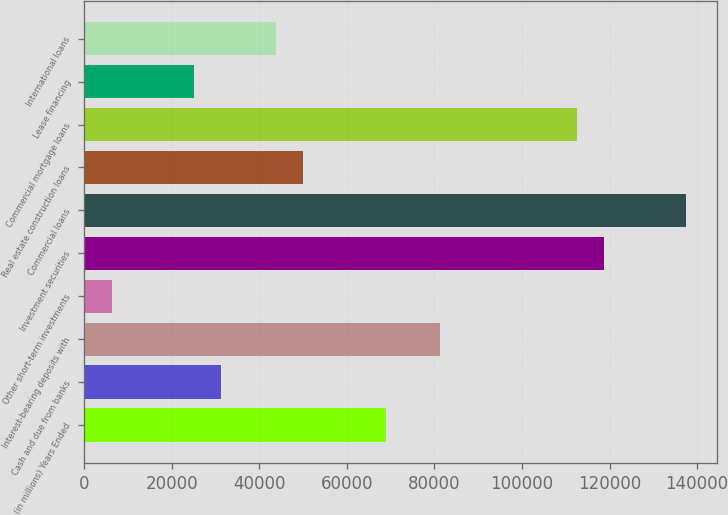Convert chart. <chart><loc_0><loc_0><loc_500><loc_500><bar_chart><fcel>(in millions) Years Ended<fcel>Cash and due from banks<fcel>Interest-bearing deposits with<fcel>Other short-term investments<fcel>Investment securities<fcel>Commercial loans<fcel>Real estate construction loans<fcel>Commercial mortgage loans<fcel>Lease financing<fcel>International loans<nl><fcel>68821.6<fcel>31324<fcel>81320.8<fcel>6325.6<fcel>118818<fcel>137567<fcel>50072.8<fcel>112569<fcel>25074.4<fcel>43823.2<nl></chart> 